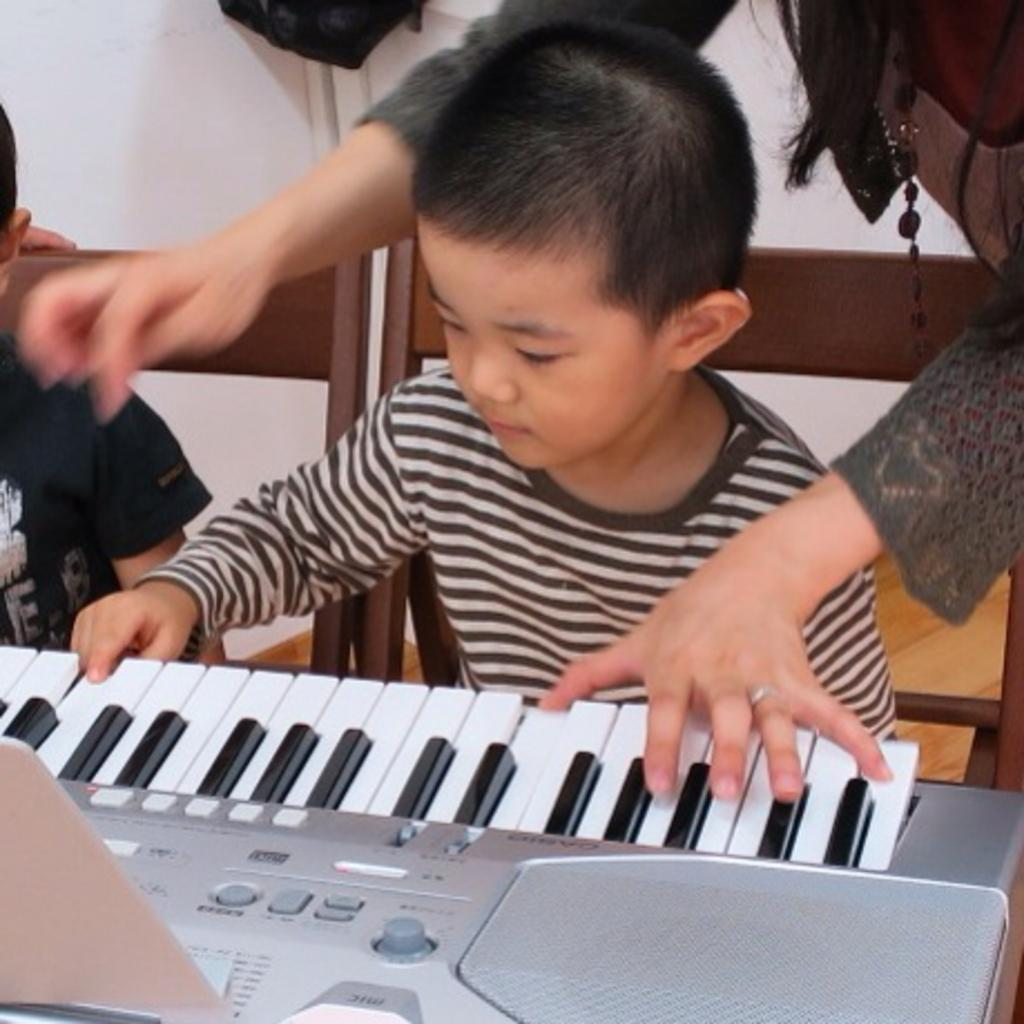What is the boy in the image doing? The boy is playing the piano in the image. Who else is present in the image besides the boy? There is a woman standing in the image. What activity is the woman engaged in? The facts provided do not specify what the woman is doing, so we cannot definitively answer this question. What type of popcorn is the boy eating while playing the piano in the image? There is no popcorn present in the image, so we cannot answer this question. 